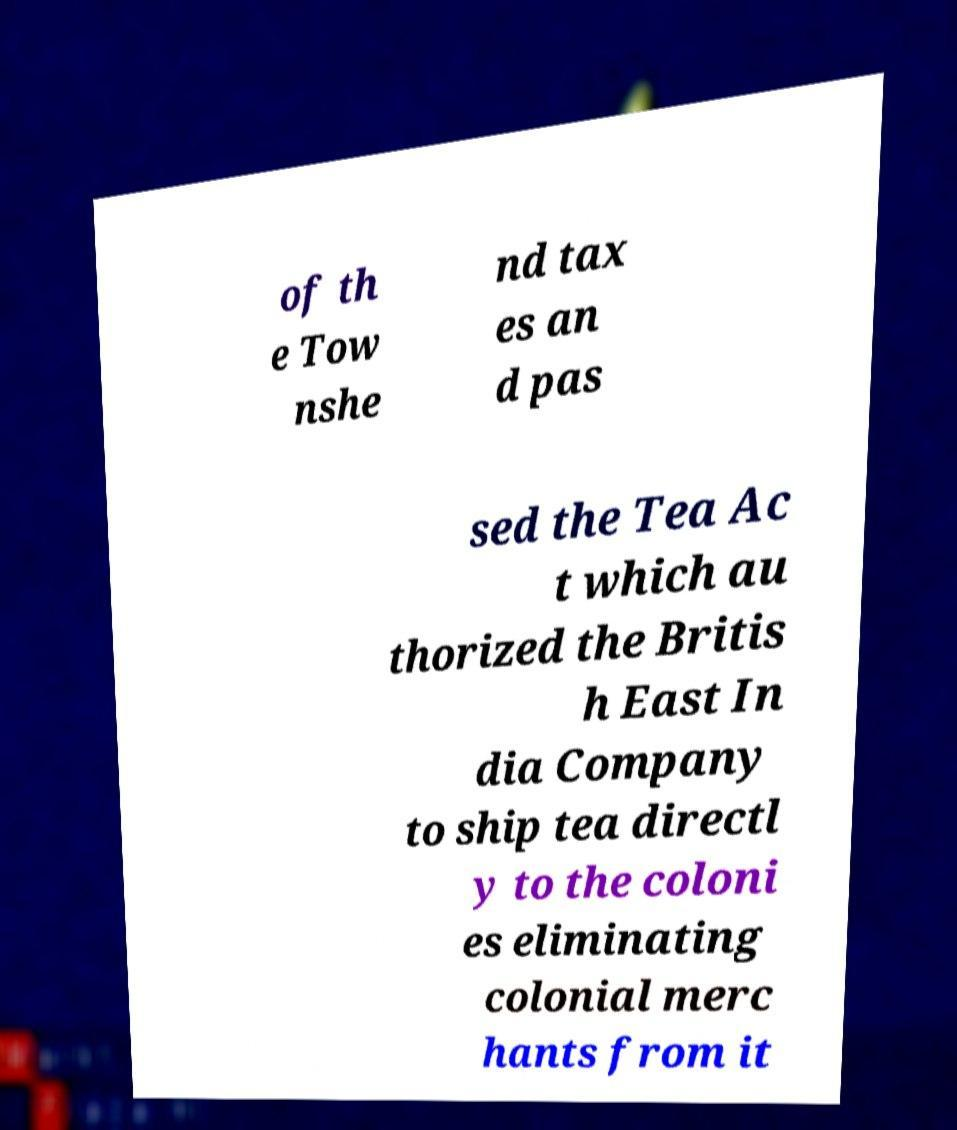Could you extract and type out the text from this image? of th e Tow nshe nd tax es an d pas sed the Tea Ac t which au thorized the Britis h East In dia Company to ship tea directl y to the coloni es eliminating colonial merc hants from it 